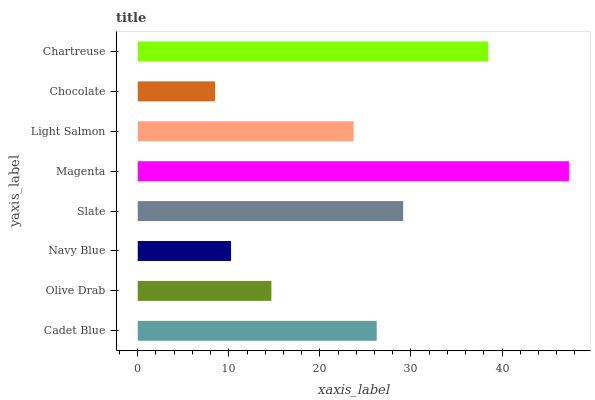Is Chocolate the minimum?
Answer yes or no. Yes. Is Magenta the maximum?
Answer yes or no. Yes. Is Olive Drab the minimum?
Answer yes or no. No. Is Olive Drab the maximum?
Answer yes or no. No. Is Cadet Blue greater than Olive Drab?
Answer yes or no. Yes. Is Olive Drab less than Cadet Blue?
Answer yes or no. Yes. Is Olive Drab greater than Cadet Blue?
Answer yes or no. No. Is Cadet Blue less than Olive Drab?
Answer yes or no. No. Is Cadet Blue the high median?
Answer yes or no. Yes. Is Light Salmon the low median?
Answer yes or no. Yes. Is Chartreuse the high median?
Answer yes or no. No. Is Navy Blue the low median?
Answer yes or no. No. 